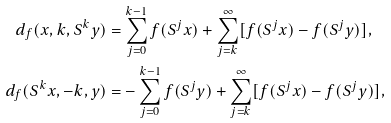Convert formula to latex. <formula><loc_0><loc_0><loc_500><loc_500>d _ { f } ( x , k , S ^ { k } y ) & = \sum _ { j = 0 } ^ { k - 1 } f ( S ^ { j } x ) + \sum _ { j = k } ^ { \infty } [ f ( S ^ { j } x ) - f ( S ^ { j } y ) ] , \\ d _ { f } ( S ^ { k } x , - k , y ) & = - \sum _ { j = 0 } ^ { k - 1 } f ( S ^ { j } y ) + \sum _ { j = k } ^ { \infty } [ f ( S ^ { j } x ) - f ( S ^ { j } y ) ] ,</formula> 